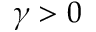Convert formula to latex. <formula><loc_0><loc_0><loc_500><loc_500>\gamma > 0</formula> 